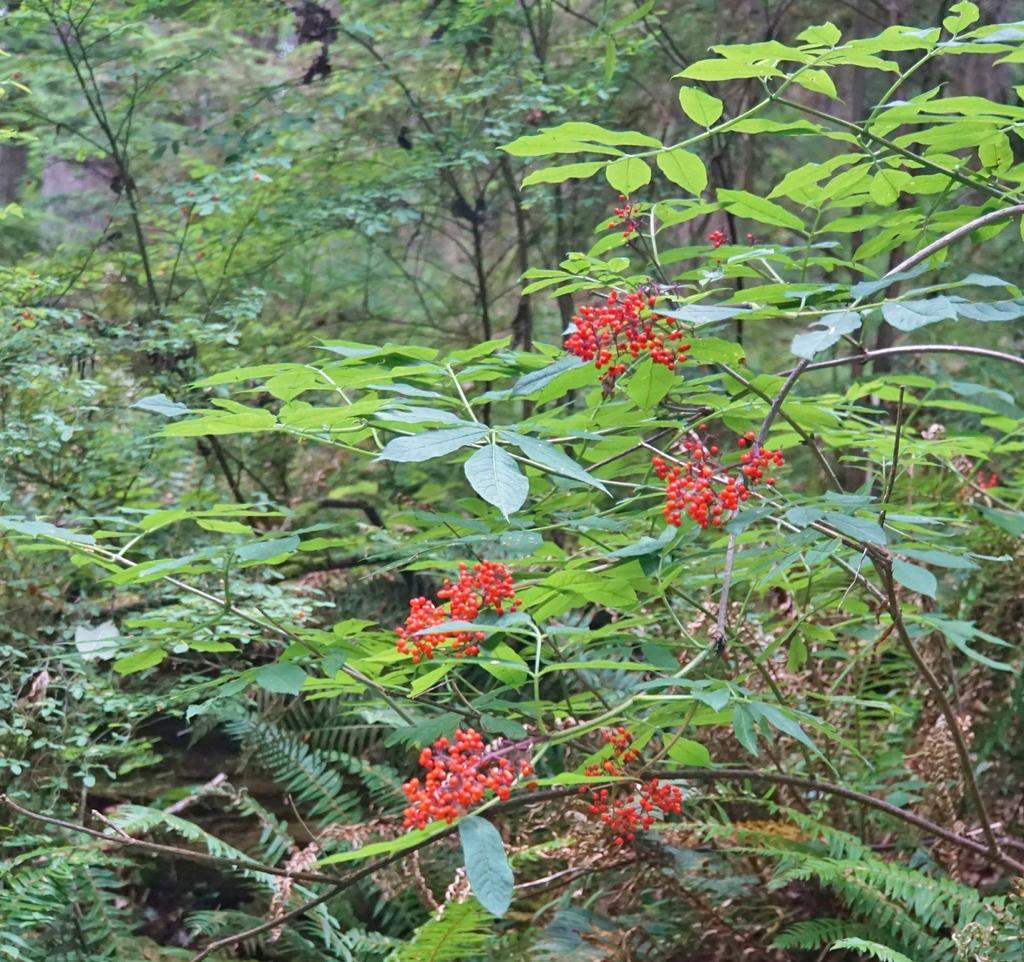What type of living organisms can be seen in the image? Plants can be seen in the image. What is the color of the buds on the plants? The plants have red color buds. Are there any ghosts visible in the image? No, there are no ghosts present in the image. What type of pig can be seen interacting with the plants in the image? There is no pig present in the image; it only features plants with red color buds. 